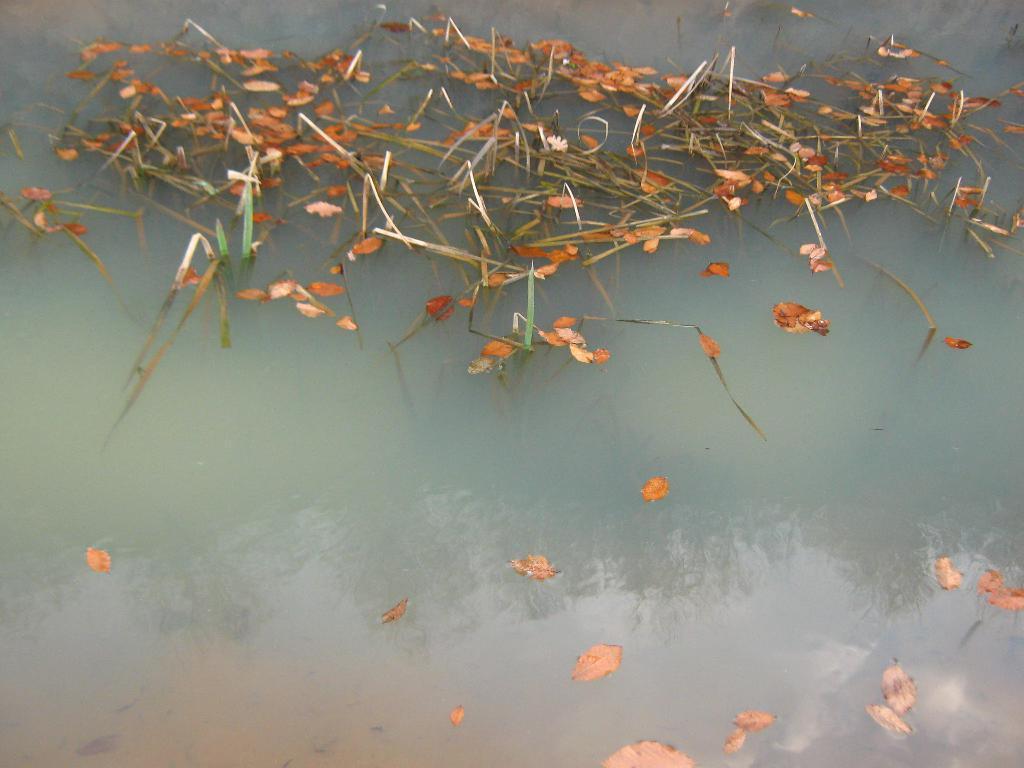Can you describe this image briefly? In this image there are dry leaves floating on the water. 